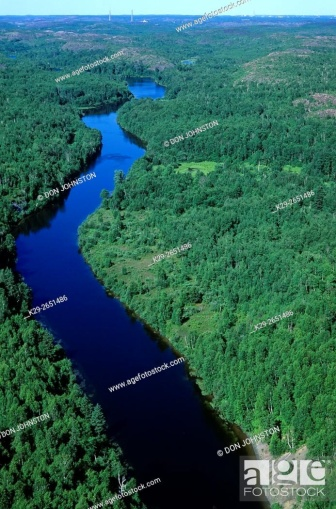What impact do you think this river might have on the local ecosystem? Rivers like this one are lifelines for their ecosystems, providing critical water sources for plants and animals. It likely contributes to the lushness of the surrounding forest, supports a complex food web that includes aquatic and terrestrial species, and may even shape the local climate by affecting humidity and temperature patterns. Additionally, the river can serve as a migration route for fish and a corridor for other wildlife, which enhances genetic diversity throughout the region. 